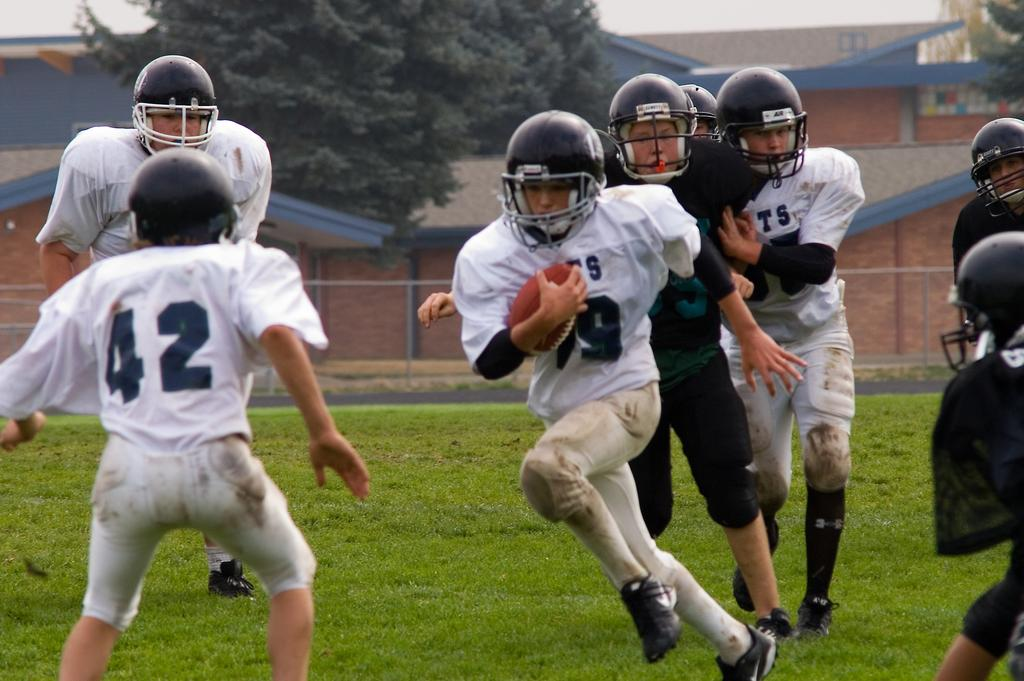What is the main subject of the image? The main subject of the image is people. Where are the people located in the image? The people are in the center of the image. What is the setting of the image? The people are on a grassland. What are the people doing in the image? The people appear to be playing. What can be seen in the background of the image? There are houses and trees in the background of the image. Who is the manager of the lamp in the image? There is no lamp present in the image, so there is no manager for it. 